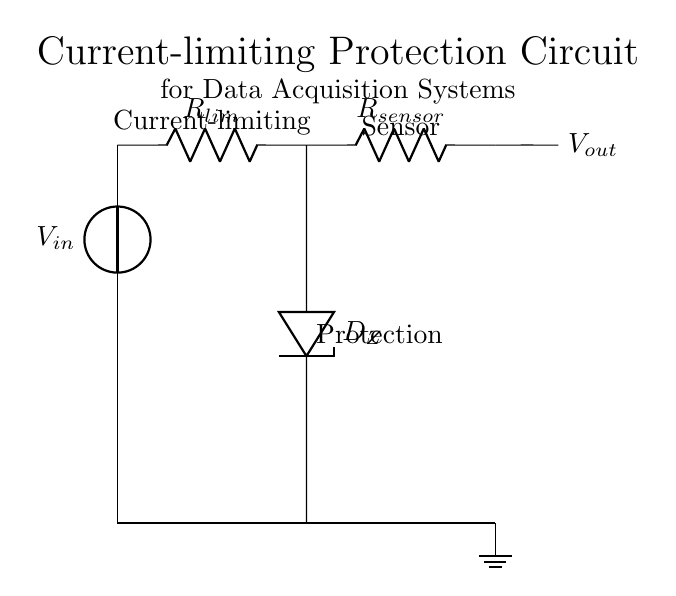What type of diode is used in this circuit? The circuit uses a Zener diode, indicated by the symbol labeled D_Z. Zener diodes are typically used for voltage regulation and protection in circuits.
Answer: Zener diode What does R_lim represent? R_lim represents the current-limiting resistor in the circuit. Its function is to restrict the current flowing to the sensor, which protects it from excessive current.
Answer: Current-limiting resistor What are the components connected in series with the input voltage? The components that are in series with the input voltage are the current-limiting resistor R_lim and the Zener diode D_Z. These components are connected in such a way that current flows through them before reaching the sensor.
Answer: Resistor and Zener diode How does this circuit protect the sensor? This circuit protects the sensor by limiting the current that can flow through it using the resistor R_lim. Additionally, the Zener diode helps to clamp the voltage to a certain level, preventing overvoltage conditions.
Answer: By limiting current and clamping voltage What is the function of the Zener diode in this configuration? The function of the Zener diode in this configuration is to prevent the output voltage from exceeding a certain threshold (clamping). This ensures that even if there is a high input voltage, the output voltage will remain within safe limits for the sensor.
Answer: Voltage clamping 